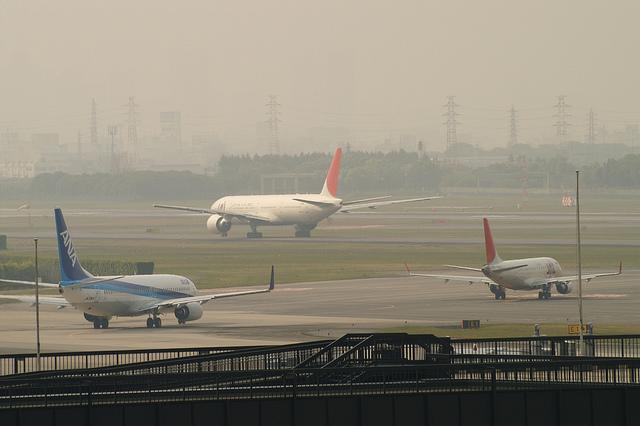Are any planes in the air?
Be succinct. No. Is it foggy?
Keep it brief. Yes. How many planes are on the airport?
Short answer required. 3. 